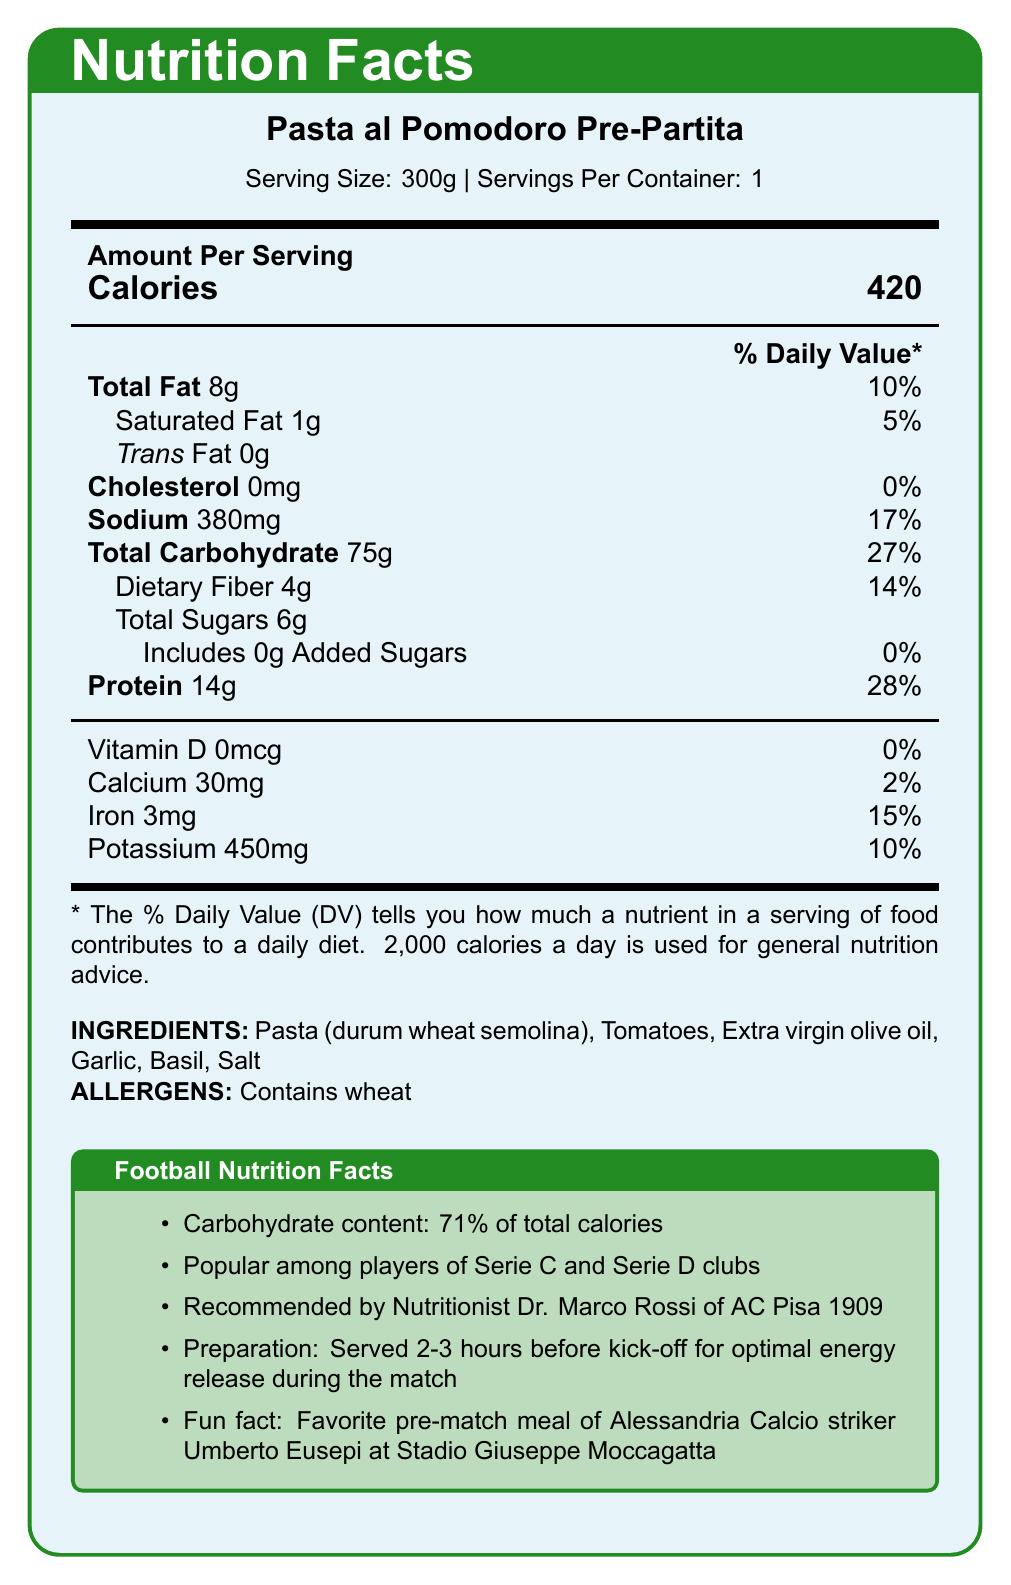what is the serving size for "Pasta al Pomodoro Pre-Partita"? The serving size information is found in the details at the top of the document.
Answer: 300g how many grams of total carbohydrates are in a serving? The total carbohydrate content per serving is specified as 75g in the nutrition facts section.
Answer: 75g how much dietary fiber does the dish contain? The dietary fiber content per serving is listed as 4g in the nutrition facts section.
Answer: 4g who recommends this dish? This recommendation is highlighted in the "Football Nutrition Facts" section at the end of the document.
Answer: Nutritionist Dr. Marco Rossi of AC Pisa 1909 what is the main carbohydrate percentage of "Pasta al Pomodoro Pre-Partita"? The carbohydrate content is noted as 71% of total calories in the "Football Nutrition Facts" section.
Answer: 71% what is the total calorie content per serving? The calorie content for a serving is shown as 420 calories in the nutrition facts section.
Answer: 420 calories which of the following is an allergen present in the dish? A. Milk B. Soy C. Wheat D. Tree Nuts The allergen information lists "Contains wheat" under the ingredients section.
Answer: C. Wheat how much protein does the dish contain? A. 10g B. 12g C. 14g D. 16g The protein content is 14g per serving, as indicated in the nutrition facts section.
Answer: C. 14g is there any vitamin D in the "Pasta al Pomodoro Pre-Partita"? The vitamin D content is 0mcg, indicating there is no vitamin D in the dish.
Answer: No summarize the main idea of the document. The main idea of the document is to present the nutrition information, consumption advice, and popularity context of "Pasta al Pomodoro Pre-Partita", making it ideal for football players before a match.
Answer: This document provides detailed nutrition facts for "Pasta al Pomodoro Pre-Partita", a popular pre-match Italian pasta dish among lower-league football players. It highlights its high carbohydrate content, modest protein, and low-fat levels. The dish is particularly favored by Serie C and Serie D players for its energy-release properties when consumed 2-3 hours before a match. It also includes endorsements and a fun fact. what is the sodium content in one serving? The sodium content per serving is listed as 380mg in the nutrition facts section.
Answer: 380mg does the dish contain any added sugars? The added sugars content is listed as 0g in the nutrition facts section.
Answer: No name one player who enjoys this dish before home games. This information is given in the "Football Nutrition Facts" section, which mentions that the dish is a favorite of Umberto Eusepi.
Answer: Umberto Eusepi how many grams of saturated fat does the dish contain? The saturated fat content is 1g per serving, as shown in the nutrition facts section.
Answer: 1g what are the main ingredients of the dish? A. Pasta and Basil B. Pasta and Tomatoes C. Tomatoes and Garlic D. Basil and Garlic The main ingredients listed are "Pasta (durum wheat semolina)" and "Tomatoes".
Answer: B. Pasta and Tomatoes which league players commonly consume this dish? A. Serie A B. Serie B C. Serie C D. Serie E The "Football Nutrition Facts" section mentions Serie C and Serie D players.
Answer: C. Serie C which vitamin is not present in the dish? A. Vitamin D B. Vitamin A C. Vitamin B D. Vitamin C The document shows that the dish contains 0mcg of vitamin D.
Answer: A. Vitamin D how many servings per container? The serving details mention that there is 1 serving per container.
Answer: 1 what is the daily value percentage of total carbohydrates in the dish? The daily value percentage of total carbohydrates is listed as 27% in the nutrition facts section.
Answer: 27% what is the fun fact mentioned about the dish? This fun fact is mentioned in the "Football Nutrition Facts" section.
Answer: Favorite pre-match meal of Alessandria Calcio striker Umberto Eusepi at Stadio Giuseppe Moccagatta how much iron does the dish contain? The iron content per serving is listed as 3mg in the nutrition facts section.
Answer: 3mg what is the recommended preparation time before a match? The "Football Nutrition Facts" section states that the dish should be served 2-3 hours before kick-off.
Answer: 2-3 hours can the total fat content be classified as high? The document provides the total fat content and the daily value percentage, but it does not specify the criteria for categorizing fat content as high.
Answer: Not enough information 